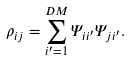<formula> <loc_0><loc_0><loc_500><loc_500>\rho _ { i j } = \sum _ { i ^ { \prime } = 1 } ^ { D M } \Psi _ { i i ^ { \prime } } \Psi _ { j i ^ { \prime } } .</formula> 